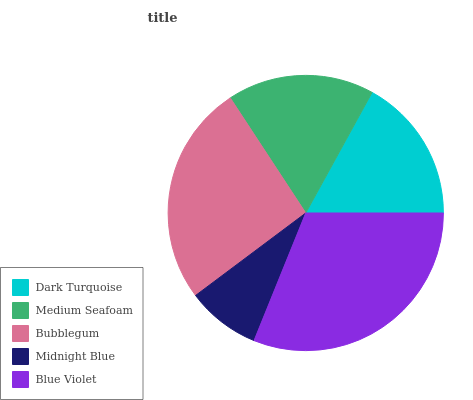Is Midnight Blue the minimum?
Answer yes or no. Yes. Is Blue Violet the maximum?
Answer yes or no. Yes. Is Medium Seafoam the minimum?
Answer yes or no. No. Is Medium Seafoam the maximum?
Answer yes or no. No. Is Medium Seafoam greater than Dark Turquoise?
Answer yes or no. Yes. Is Dark Turquoise less than Medium Seafoam?
Answer yes or no. Yes. Is Dark Turquoise greater than Medium Seafoam?
Answer yes or no. No. Is Medium Seafoam less than Dark Turquoise?
Answer yes or no. No. Is Medium Seafoam the high median?
Answer yes or no. Yes. Is Medium Seafoam the low median?
Answer yes or no. Yes. Is Dark Turquoise the high median?
Answer yes or no. No. Is Bubblegum the low median?
Answer yes or no. No. 